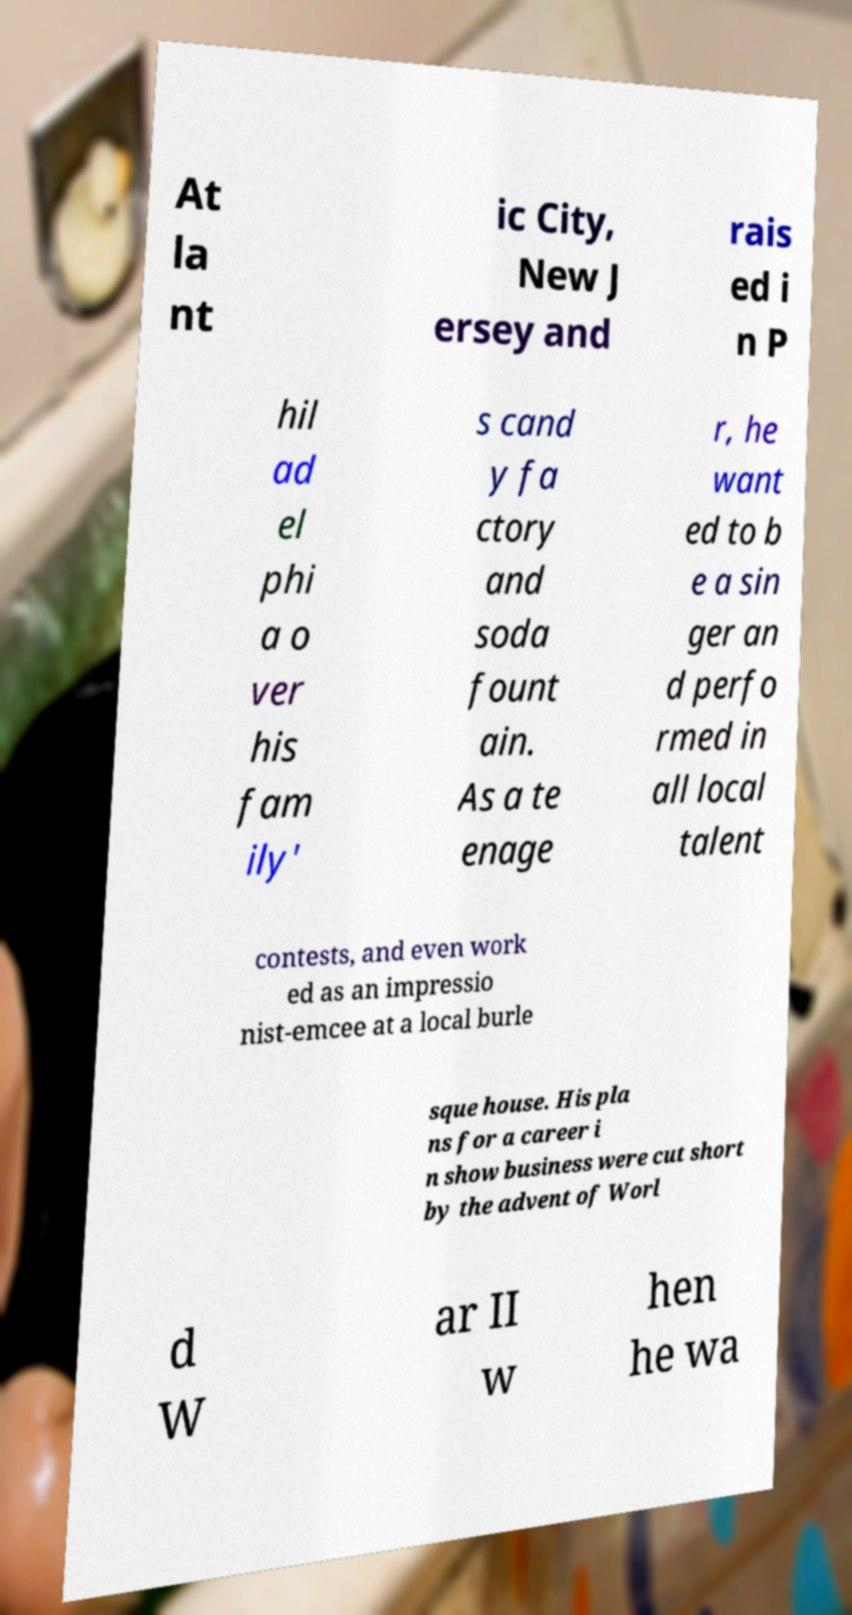Please identify and transcribe the text found in this image. At la nt ic City, New J ersey and rais ed i n P hil ad el phi a o ver his fam ily' s cand y fa ctory and soda fount ain. As a te enage r, he want ed to b e a sin ger an d perfo rmed in all local talent contests, and even work ed as an impressio nist-emcee at a local burle sque house. His pla ns for a career i n show business were cut short by the advent of Worl d W ar II w hen he wa 